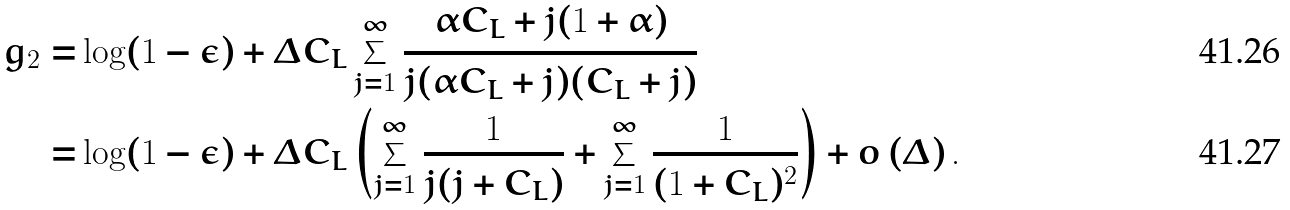<formula> <loc_0><loc_0><loc_500><loc_500>g _ { 2 } = & \log ( 1 - \epsilon ) + \Delta C _ { L } \sum _ { j = 1 } ^ { \infty } \frac { \alpha C _ { L } + j ( 1 + \alpha ) } { j ( \alpha C _ { L } + j ) ( C _ { L } + j ) } \\ = & \log ( 1 - \epsilon ) + \Delta C _ { L } \left ( \sum _ { j = 1 } ^ { \infty } \frac { 1 } { j ( j + C _ { L } ) } + \sum _ { j = 1 } ^ { \infty } \frac { 1 } { ( 1 + C _ { L } ) ^ { 2 } } \right ) + o \left ( \Delta \right ) .</formula> 